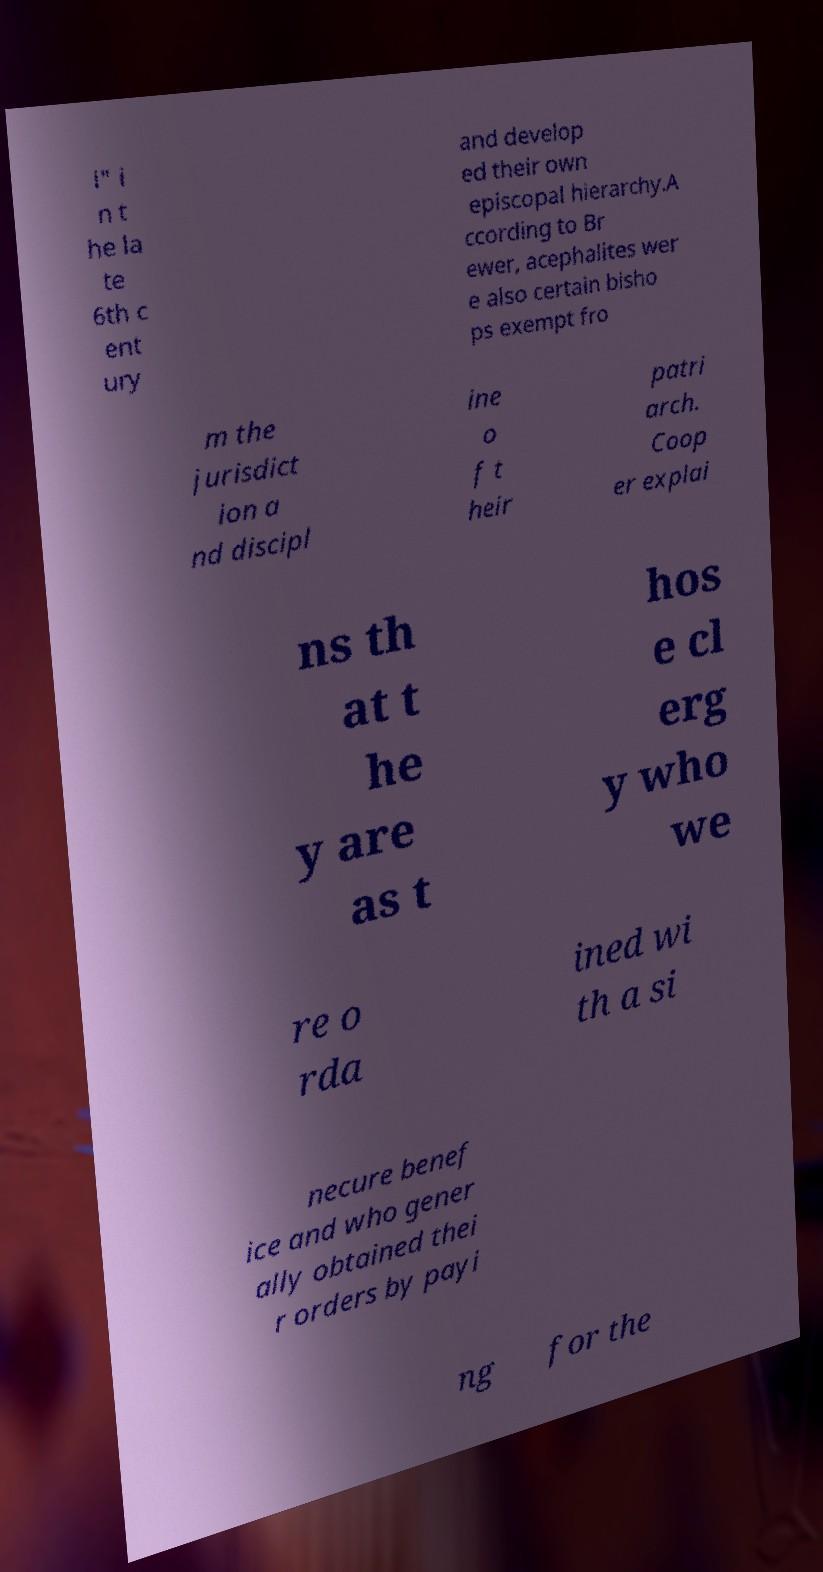Can you accurately transcribe the text from the provided image for me? i" i n t he la te 6th c ent ury and develop ed their own episcopal hierarchy.A ccording to Br ewer, acephalites wer e also certain bisho ps exempt fro m the jurisdict ion a nd discipl ine o f t heir patri arch. Coop er explai ns th at t he y are as t hos e cl erg y who we re o rda ined wi th a si necure benef ice and who gener ally obtained thei r orders by payi ng for the 